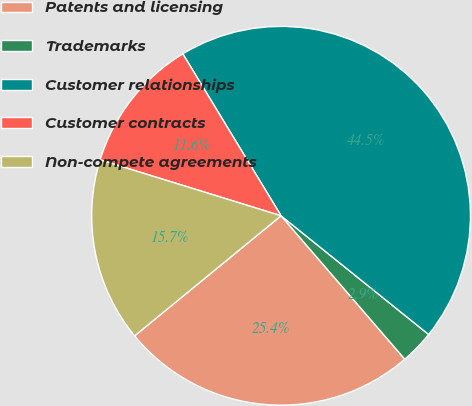Convert chart. <chart><loc_0><loc_0><loc_500><loc_500><pie_chart><fcel>Patents and licensing<fcel>Trademarks<fcel>Customer relationships<fcel>Customer contracts<fcel>Non-compete agreements<nl><fcel>25.4%<fcel>2.89%<fcel>44.46%<fcel>11.55%<fcel>15.7%<nl></chart> 